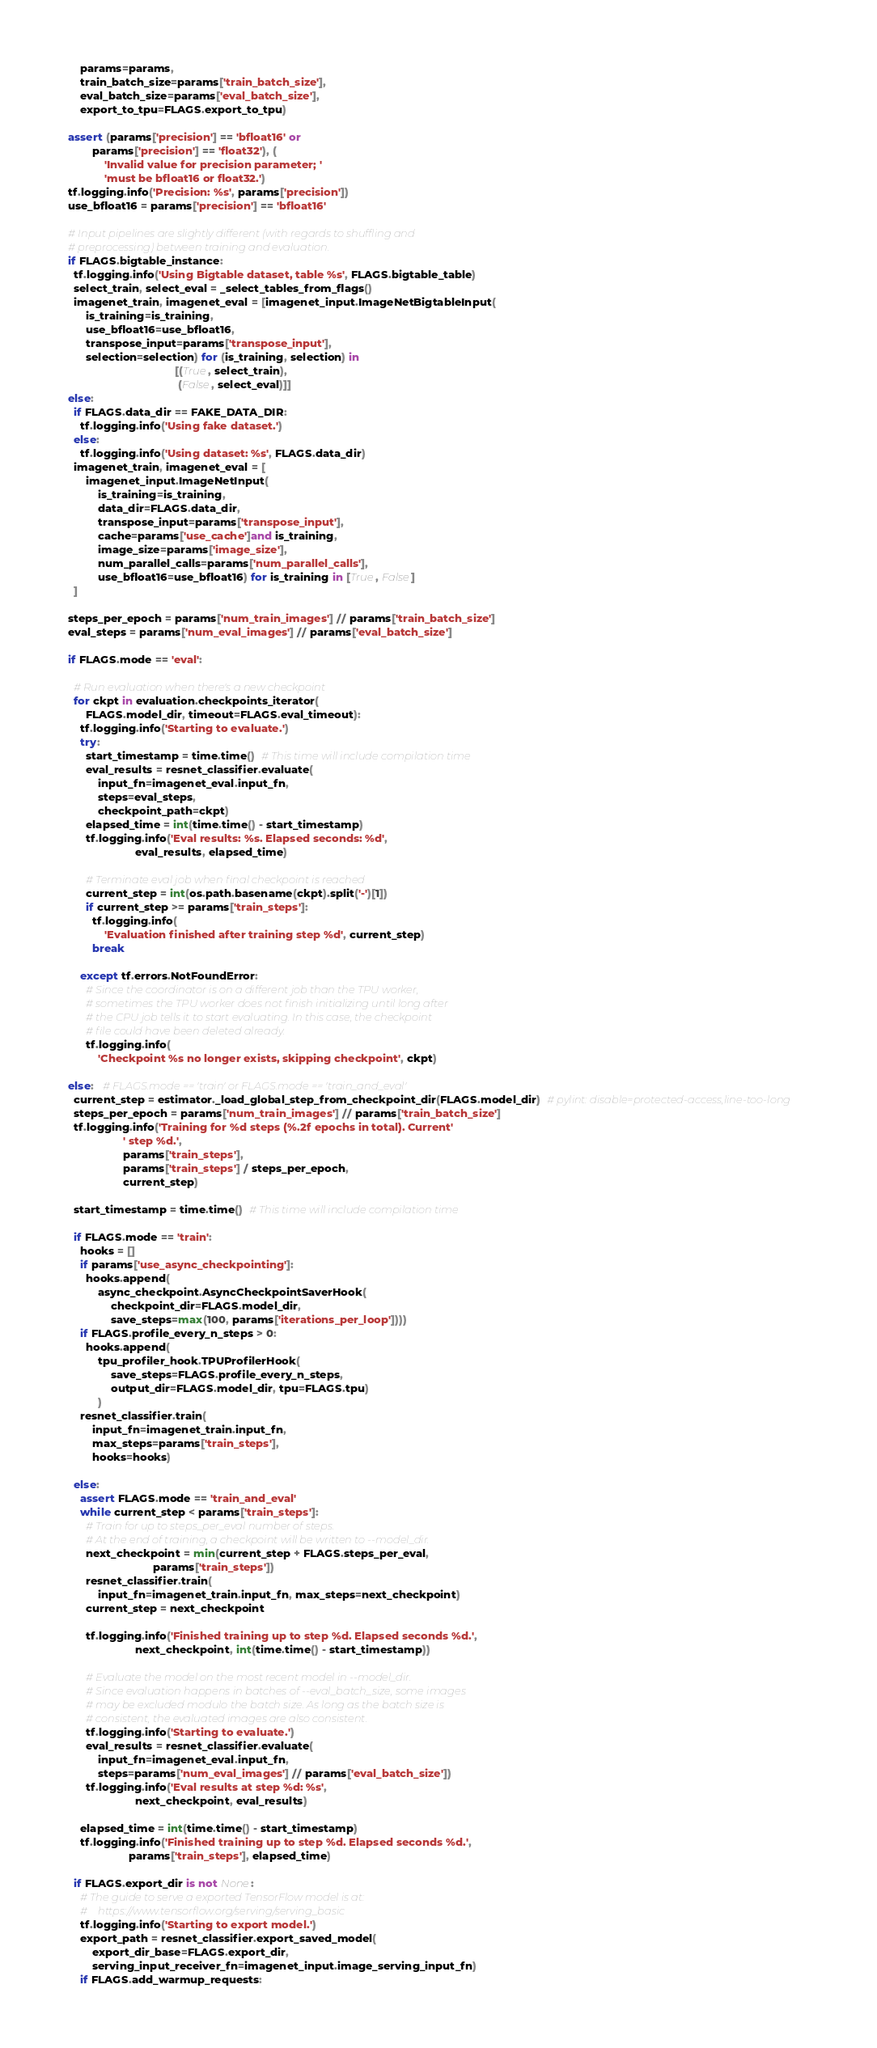<code> <loc_0><loc_0><loc_500><loc_500><_Python_>      params=params,
      train_batch_size=params['train_batch_size'],
      eval_batch_size=params['eval_batch_size'],
      export_to_tpu=FLAGS.export_to_tpu)

  assert (params['precision'] == 'bfloat16' or
          params['precision'] == 'float32'), (
              'Invalid value for precision parameter; '
              'must be bfloat16 or float32.')
  tf.logging.info('Precision: %s', params['precision'])
  use_bfloat16 = params['precision'] == 'bfloat16'

  # Input pipelines are slightly different (with regards to shuffling and
  # preprocessing) between training and evaluation.
  if FLAGS.bigtable_instance:
    tf.logging.info('Using Bigtable dataset, table %s', FLAGS.bigtable_table)
    select_train, select_eval = _select_tables_from_flags()
    imagenet_train, imagenet_eval = [imagenet_input.ImageNetBigtableInput(
        is_training=is_training,
        use_bfloat16=use_bfloat16,
        transpose_input=params['transpose_input'],
        selection=selection) for (is_training, selection) in
                                     [(True, select_train),
                                      (False, select_eval)]]
  else:
    if FLAGS.data_dir == FAKE_DATA_DIR:
      tf.logging.info('Using fake dataset.')
    else:
      tf.logging.info('Using dataset: %s', FLAGS.data_dir)
    imagenet_train, imagenet_eval = [
        imagenet_input.ImageNetInput(
            is_training=is_training,
            data_dir=FLAGS.data_dir,
            transpose_input=params['transpose_input'],
            cache=params['use_cache']and is_training,
            image_size=params['image_size'],
            num_parallel_calls=params['num_parallel_calls'],
            use_bfloat16=use_bfloat16) for is_training in [True, False]
    ]

  steps_per_epoch = params['num_train_images'] // params['train_batch_size']
  eval_steps = params['num_eval_images'] // params['eval_batch_size']

  if FLAGS.mode == 'eval':

    # Run evaluation when there's a new checkpoint
    for ckpt in evaluation.checkpoints_iterator(
        FLAGS.model_dir, timeout=FLAGS.eval_timeout):
      tf.logging.info('Starting to evaluate.')
      try:
        start_timestamp = time.time()  # This time will include compilation time
        eval_results = resnet_classifier.evaluate(
            input_fn=imagenet_eval.input_fn,
            steps=eval_steps,
            checkpoint_path=ckpt)
        elapsed_time = int(time.time() - start_timestamp)
        tf.logging.info('Eval results: %s. Elapsed seconds: %d',
                        eval_results, elapsed_time)

        # Terminate eval job when final checkpoint is reached
        current_step = int(os.path.basename(ckpt).split('-')[1])
        if current_step >= params['train_steps']:
          tf.logging.info(
              'Evaluation finished after training step %d', current_step)
          break

      except tf.errors.NotFoundError:
        # Since the coordinator is on a different job than the TPU worker,
        # sometimes the TPU worker does not finish initializing until long after
        # the CPU job tells it to start evaluating. In this case, the checkpoint
        # file could have been deleted already.
        tf.logging.info(
            'Checkpoint %s no longer exists, skipping checkpoint', ckpt)

  else:   # FLAGS.mode == 'train' or FLAGS.mode == 'train_and_eval'
    current_step = estimator._load_global_step_from_checkpoint_dir(FLAGS.model_dir)  # pylint: disable=protected-access,line-too-long
    steps_per_epoch = params['num_train_images'] // params['train_batch_size']
    tf.logging.info('Training for %d steps (%.2f epochs in total). Current'
                    ' step %d.',
                    params['train_steps'],
                    params['train_steps'] / steps_per_epoch,
                    current_step)

    start_timestamp = time.time()  # This time will include compilation time

    if FLAGS.mode == 'train':
      hooks = []
      if params['use_async_checkpointing']:
        hooks.append(
            async_checkpoint.AsyncCheckpointSaverHook(
                checkpoint_dir=FLAGS.model_dir,
                save_steps=max(100, params['iterations_per_loop'])))
      if FLAGS.profile_every_n_steps > 0:
        hooks.append(
            tpu_profiler_hook.TPUProfilerHook(
                save_steps=FLAGS.profile_every_n_steps,
                output_dir=FLAGS.model_dir, tpu=FLAGS.tpu)
            )
      resnet_classifier.train(
          input_fn=imagenet_train.input_fn,
          max_steps=params['train_steps'],
          hooks=hooks)

    else:
      assert FLAGS.mode == 'train_and_eval'
      while current_step < params['train_steps']:
        # Train for up to steps_per_eval number of steps.
        # At the end of training, a checkpoint will be written to --model_dir.
        next_checkpoint = min(current_step + FLAGS.steps_per_eval,
                              params['train_steps'])
        resnet_classifier.train(
            input_fn=imagenet_train.input_fn, max_steps=next_checkpoint)
        current_step = next_checkpoint

        tf.logging.info('Finished training up to step %d. Elapsed seconds %d.',
                        next_checkpoint, int(time.time() - start_timestamp))

        # Evaluate the model on the most recent model in --model_dir.
        # Since evaluation happens in batches of --eval_batch_size, some images
        # may be excluded modulo the batch size. As long as the batch size is
        # consistent, the evaluated images are also consistent.
        tf.logging.info('Starting to evaluate.')
        eval_results = resnet_classifier.evaluate(
            input_fn=imagenet_eval.input_fn,
            steps=params['num_eval_images'] // params['eval_batch_size'])
        tf.logging.info('Eval results at step %d: %s',
                        next_checkpoint, eval_results)

      elapsed_time = int(time.time() - start_timestamp)
      tf.logging.info('Finished training up to step %d. Elapsed seconds %d.',
                      params['train_steps'], elapsed_time)

    if FLAGS.export_dir is not None:
      # The guide to serve a exported TensorFlow model is at:
      #    https://www.tensorflow.org/serving/serving_basic
      tf.logging.info('Starting to export model.')
      export_path = resnet_classifier.export_saved_model(
          export_dir_base=FLAGS.export_dir,
          serving_input_receiver_fn=imagenet_input.image_serving_input_fn)
      if FLAGS.add_warmup_requests:</code> 